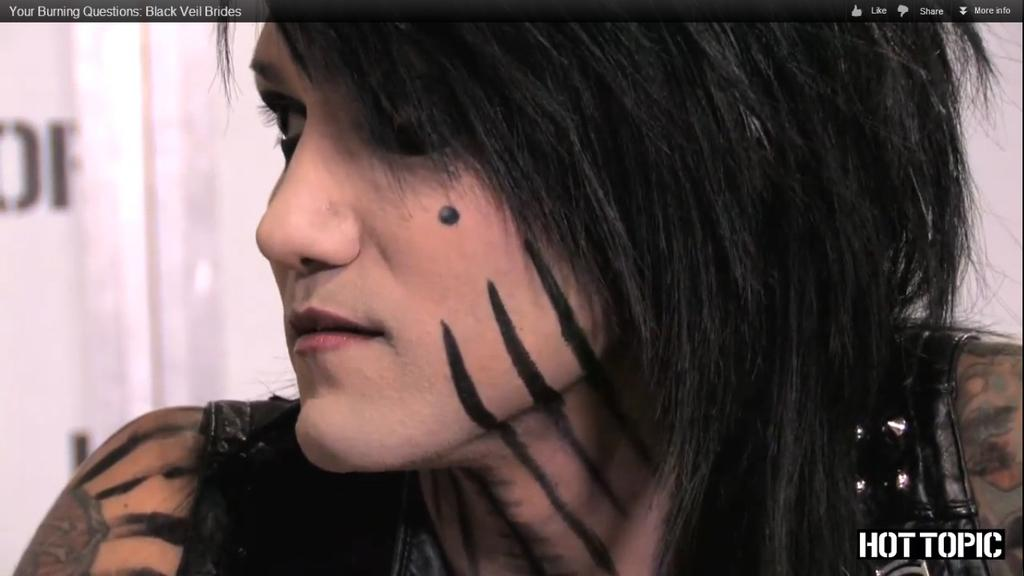Who is the main subject in the image? There is a woman in the image. What distinguishing features does the woman have? The woman has tattoos on her body. What additional information is provided at the top and bottom of the image? There is text written at the top and bottom of the image. Can you describe the background of the image? The background of the image is not clear. What type of sail can be seen in the image? There is no sail present in the image. How many loaves of bread are visible in the image? There are no loaves of bread present in the image. 